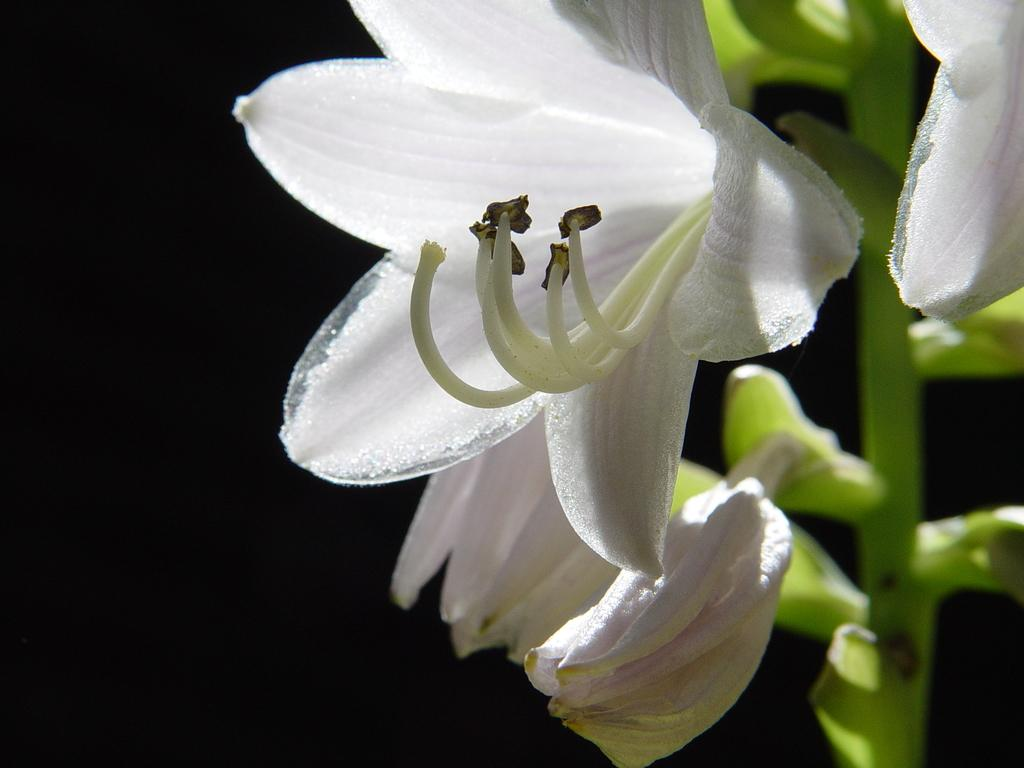What type of living organisms can be seen in the image? There are flowers in the image. What is the color of the background in the image? The background of the image is dark. Is the queen present in the image, walking among the flowers? There is no queen or indication of walking in the image; it only features flowers and a dark background. 